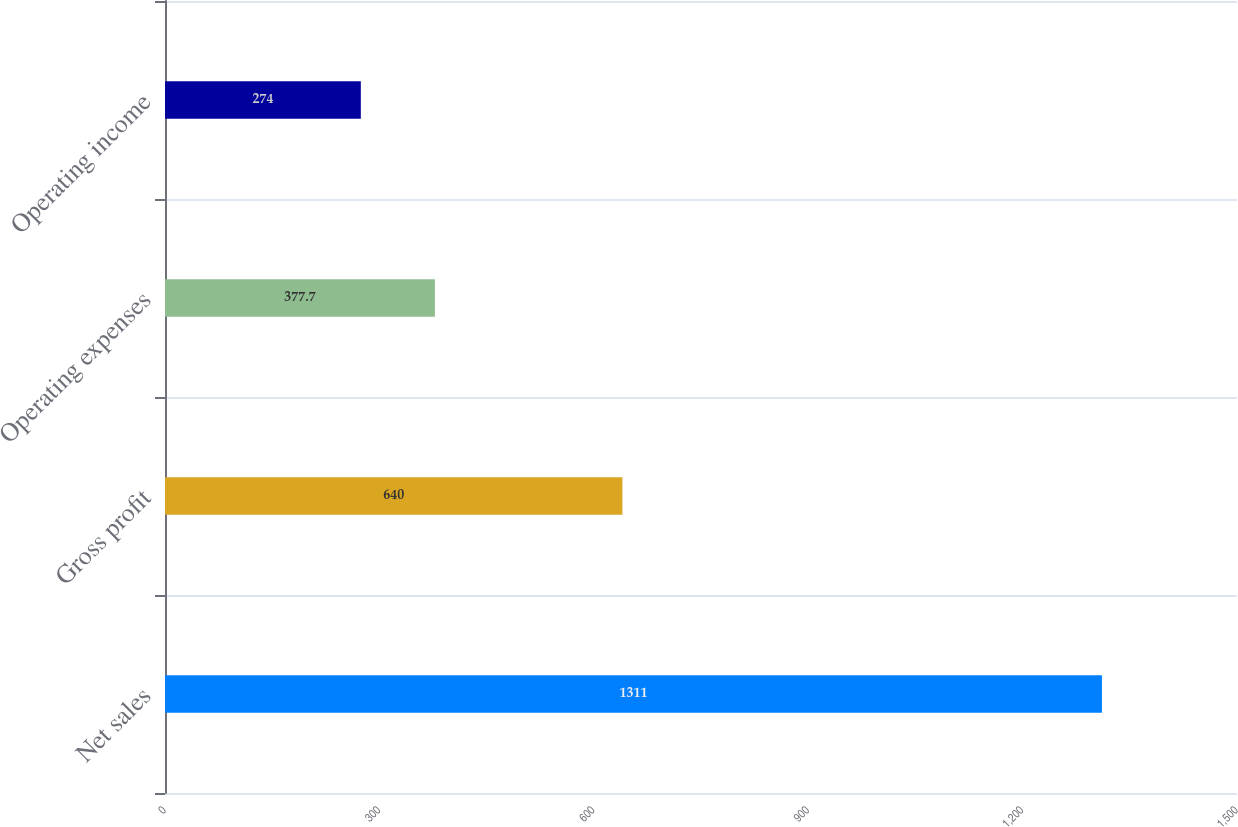<chart> <loc_0><loc_0><loc_500><loc_500><bar_chart><fcel>Net sales<fcel>Gross profit<fcel>Operating expenses<fcel>Operating income<nl><fcel>1311<fcel>640<fcel>377.7<fcel>274<nl></chart> 